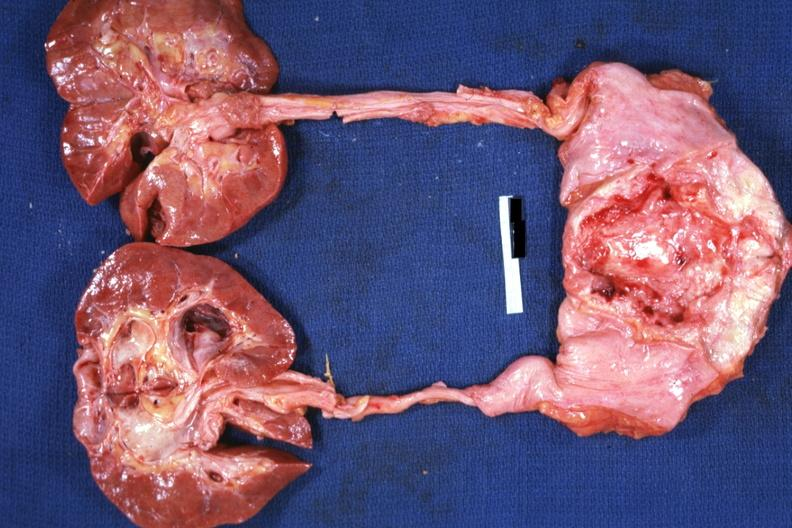what is present?
Answer the question using a single word or phrase. Adenocarcinoma 